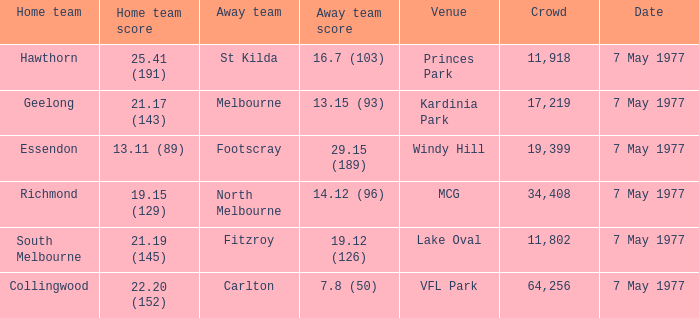Name the home team score for larger crowd than 11,918 for windy hill venue 13.11 (89). 